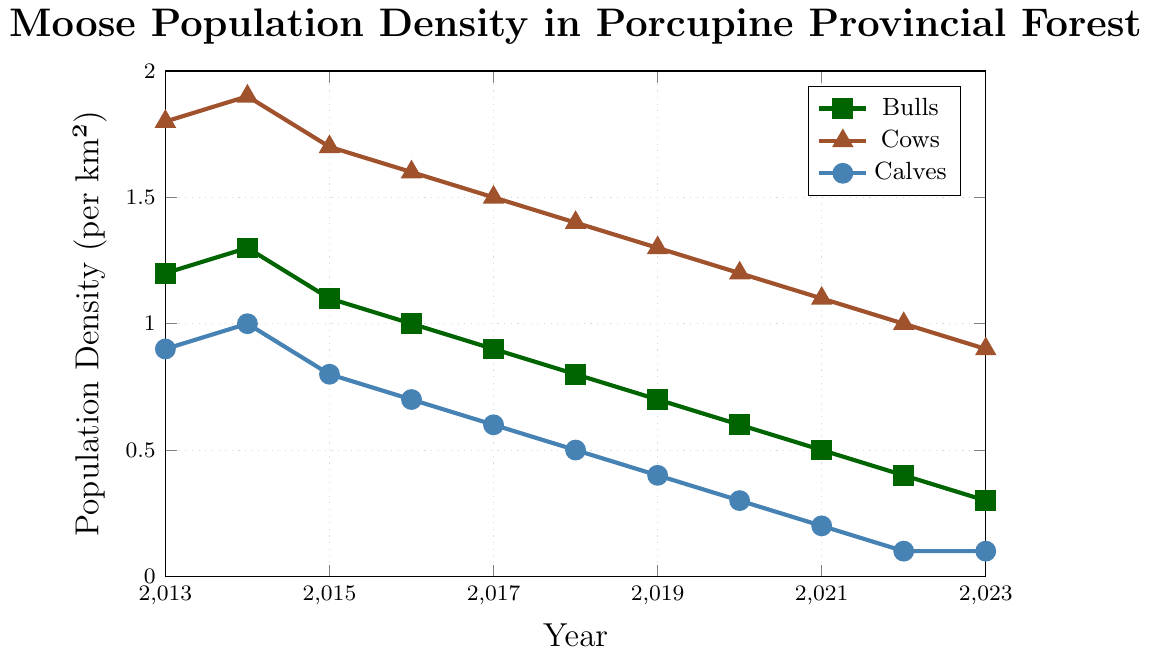What was the population density of bulls in 2020? Locate the year 2020 on the x-axis and find the corresponding point on the bulls' line. The y-coordinate of that point indicates the population density.
Answer: 0.6 How did the population density of cows change from 2013 to 2023? Look at the cows' line, starting at 1.8 in 2013 and ending at 0.9 in 2023. This indicates a steady decrease over the decade.
Answer: Decreased by 0.9 Between which years did the population density of calves drop the most sharply? Observe the calves' line and identify the steepest decline. The most significant drop is from 2014 to 2015.
Answer: 2014-2015 Which year had the highest overall population density of moose (bulls + cows + calves)? Add the population densities of bulls, cows, and calves for each year and find the maximum sum. The highest combined value is in 2014.
Answer: 2014 In which year did the population density of cows become twice that of bulls? Locate the year where the ratio of the population density of cows to bulls is approximately 2:1. This occurs in 2019.
Answer: 2019 What was the average population density of calves over the decade? Sum the population densities of calves for each year and divide by the number of years (11). The calculation is (0.9+1.0+0.8+0.7+0.6+0.5+0.4+0.3+0.2+0.1+0.1) / 11 = 0.525.
Answer: 0.525 How much less was the bulls' population density compared to cows' in 2017? Subtract the bulls' population density in 2017 from the cows'. The calculation is 1.5 - 0.9 = 0.6.
Answer: 0.6 Across the decade, which population group showed the most significant overall decline? Compare the initial and final values of each group over the decade. Bulls decreased from 1.2 to 0.3, cows from 1.8 to 0.9, and calves from 0.9 to 0.1. The largest decline, in absolute terms, is for cows (0.9).
Answer: Cows Is there any year where the population density of bulls was higher than both cows and calves? Check the values for each year. There is no year where bulls are higher than both cows and calves simultaneously.
Answer: No 